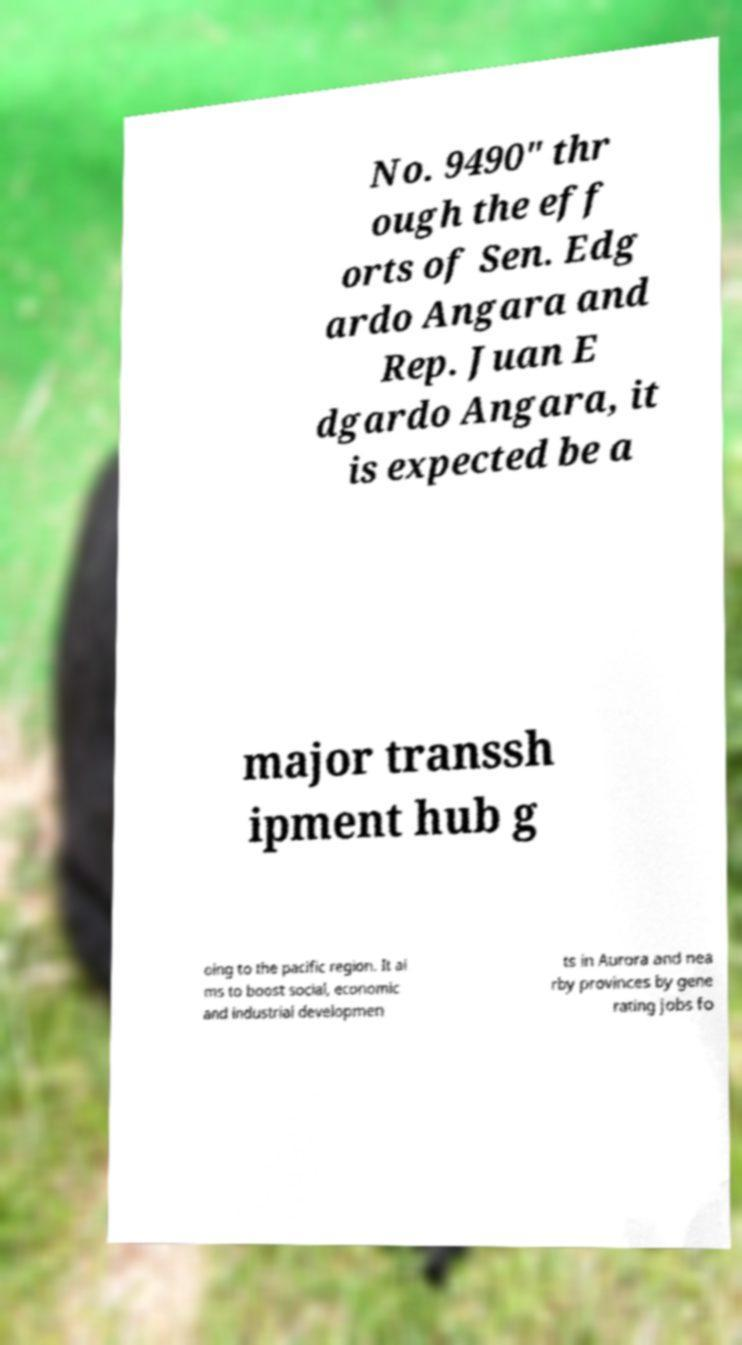Please read and relay the text visible in this image. What does it say? No. 9490" thr ough the eff orts of Sen. Edg ardo Angara and Rep. Juan E dgardo Angara, it is expected be a major transsh ipment hub g oing to the pacific region. It ai ms to boost social, economic and industrial developmen ts in Aurora and nea rby provinces by gene rating jobs fo 